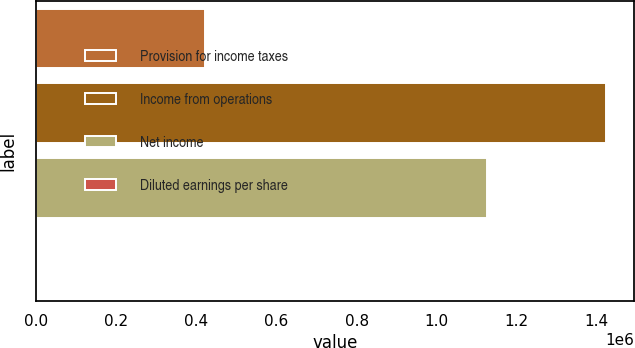Convert chart. <chart><loc_0><loc_0><loc_500><loc_500><bar_chart><fcel>Provision for income taxes<fcel>Income from operations<fcel>Net income<fcel>Diluted earnings per share<nl><fcel>421418<fcel>1.42296e+06<fcel>1.12564e+06<fcel>0.79<nl></chart> 